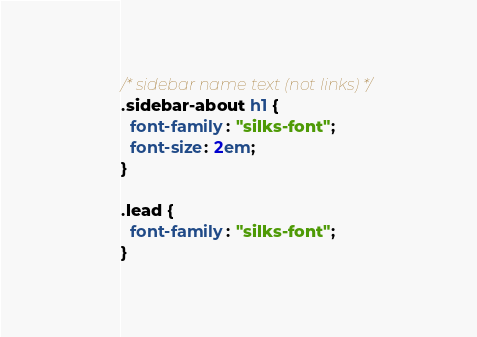Convert code to text. <code><loc_0><loc_0><loc_500><loc_500><_CSS_>/* sidebar name text (not links) */
.sidebar-about h1 {
  font-family: "silks-font";
  font-size: 2em;
}

.lead {
  font-family: "silks-font";
}
</code> 